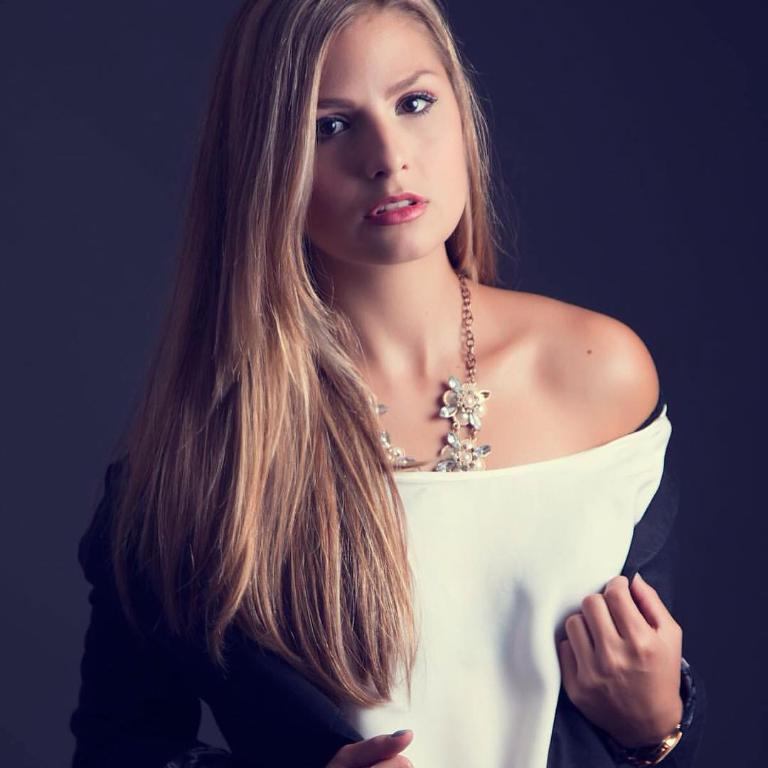Who is present in the image? There is a woman in the image. What is the woman wearing on her upper body? The woman is wearing a white dress and a jacket. What accessories is the woman wearing? The woman is wearing a wrist watch and a chain. What can be observed about the background of the image? The background of the image is dark. What type of ground can be seen beneath the woman in the image? There is no ground visible beneath the woman in the image; she appears to be standing or sitting on a surface that is not discernible. 